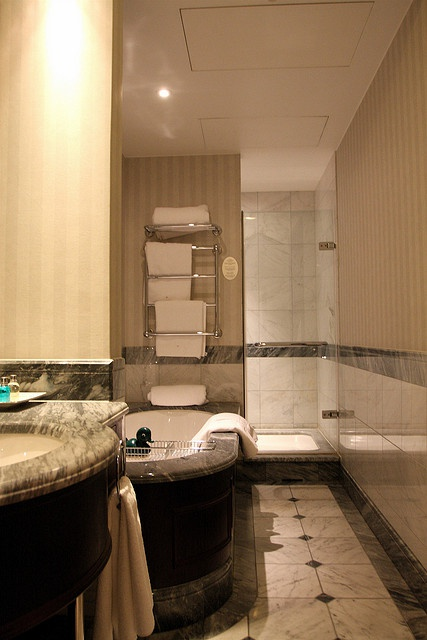Describe the objects in this image and their specific colors. I can see sink in tan tones and sink in tan and gray tones in this image. 